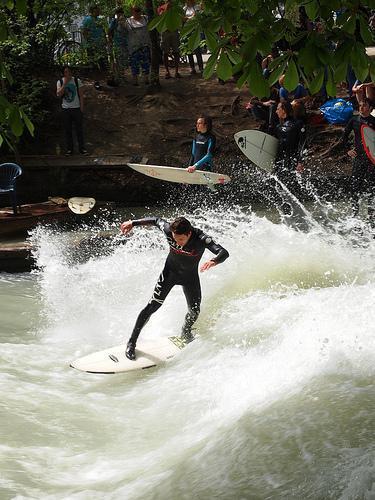How many people are currently on waves?
Give a very brief answer. 1. 